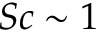Convert formula to latex. <formula><loc_0><loc_0><loc_500><loc_500>S c \sim 1</formula> 